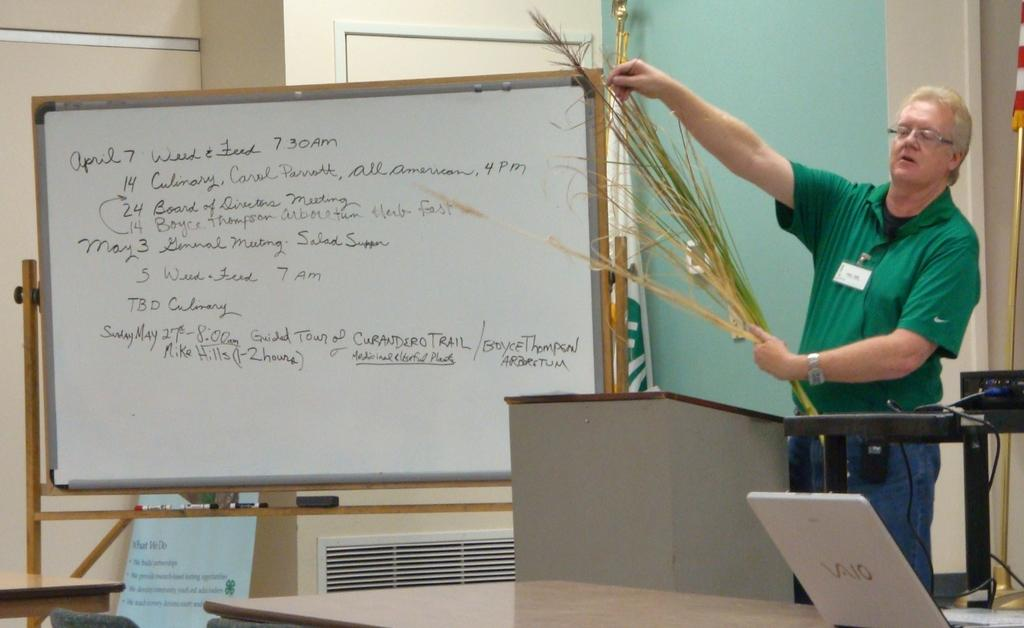Provide a one-sentence caption for the provided image. A man stands besides a white board that has the date of April 7th. 